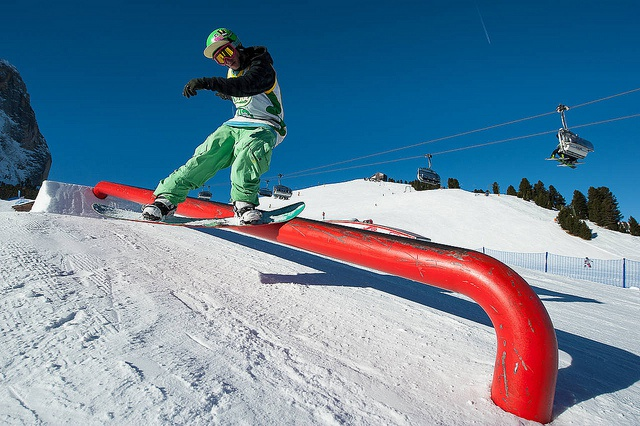Describe the objects in this image and their specific colors. I can see people in darkblue, black, teal, darkgreen, and lightgreen tones, snowboard in darkblue, lightgray, blue, black, and darkgray tones, people in darkblue, black, blue, and navy tones, people in darkblue, black, and purple tones, and people in darkblue, darkgray, gray, lavender, and lightblue tones in this image. 